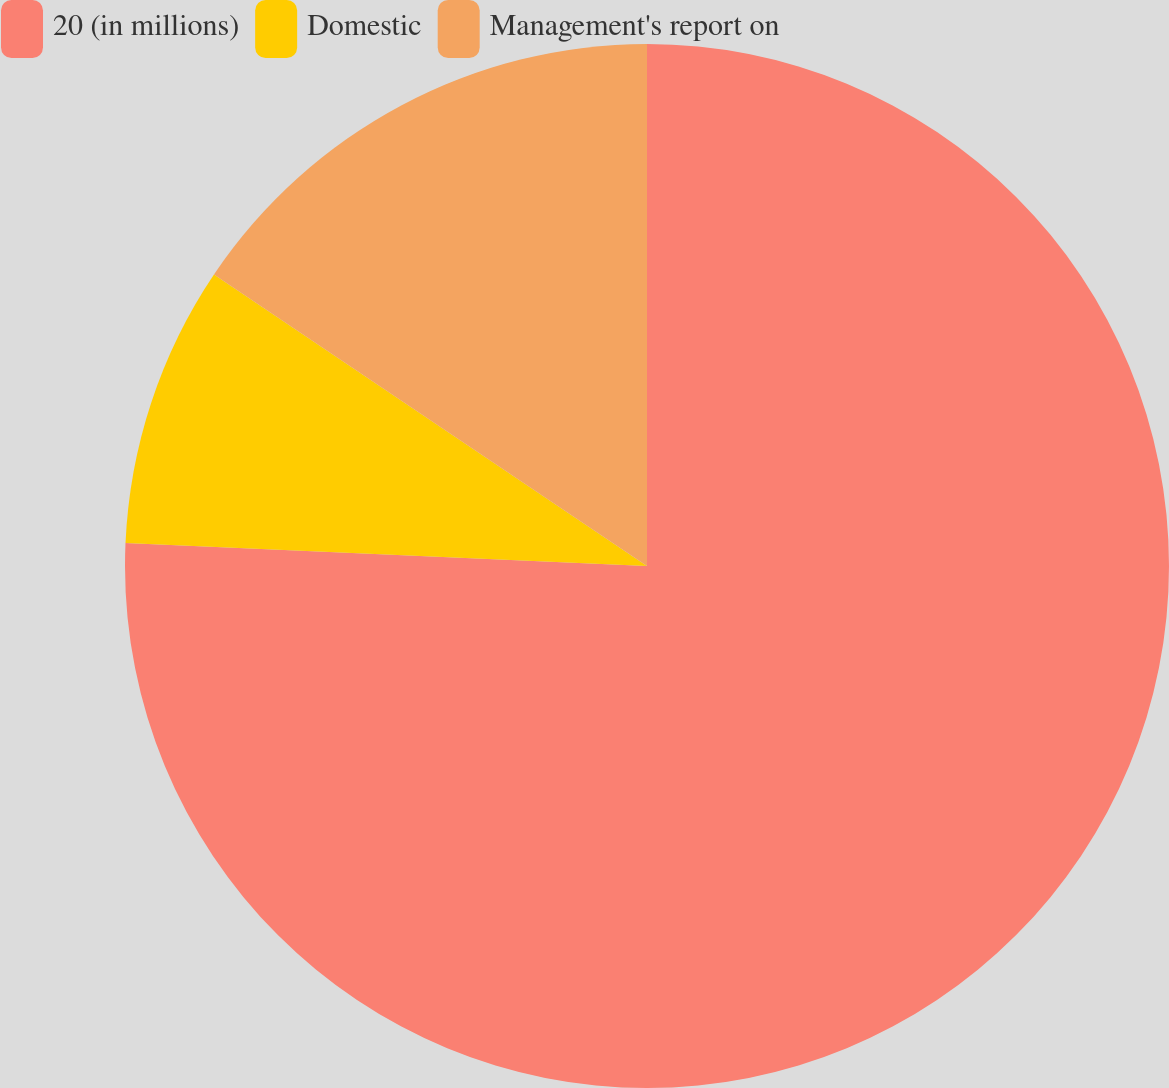<chart> <loc_0><loc_0><loc_500><loc_500><pie_chart><fcel>20 (in millions)<fcel>Domestic<fcel>Management's report on<nl><fcel>75.7%<fcel>8.73%<fcel>15.57%<nl></chart> 